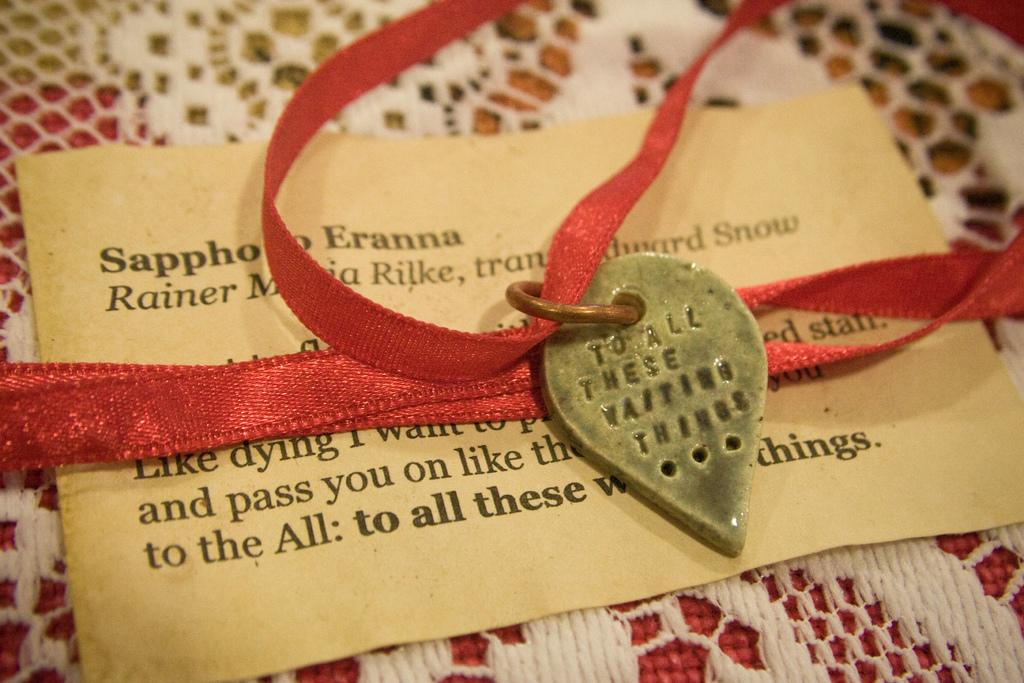What is attached to the red ribbon in the image? There is a lock attached to the red ribbon in the image. What is the red ribbon with a lock placed on? The red ribbon with a lock is placed on a paper. What can be read on the paper? There is text visible on the paper. How is the paper supported in the image? The paper is on a net cloth. How many lizards are crawling on the paper in the image? There are no lizards present in the image. What type of lunch is being served on the paper in the image? There is no lunch visible in the image; it features a red ribbon with a lock on a paper with text. 